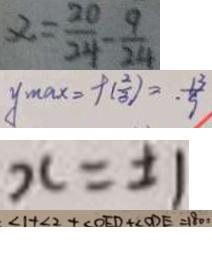Convert formula to latex. <formula><loc_0><loc_0><loc_500><loc_500>\alpha = \frac { 2 0 } { 2 4 } - \frac { 9 } { 2 4 } 
 y _ { \max } = f ( \frac { 2 } { 3 } ) = . \frac { 1 3 } { 9 } 
 x = \pm 1 
 \angle 1 + \angle 2 + \angle O E D + \angle O D E = 1 8 0 ^ { \circ }</formula> 